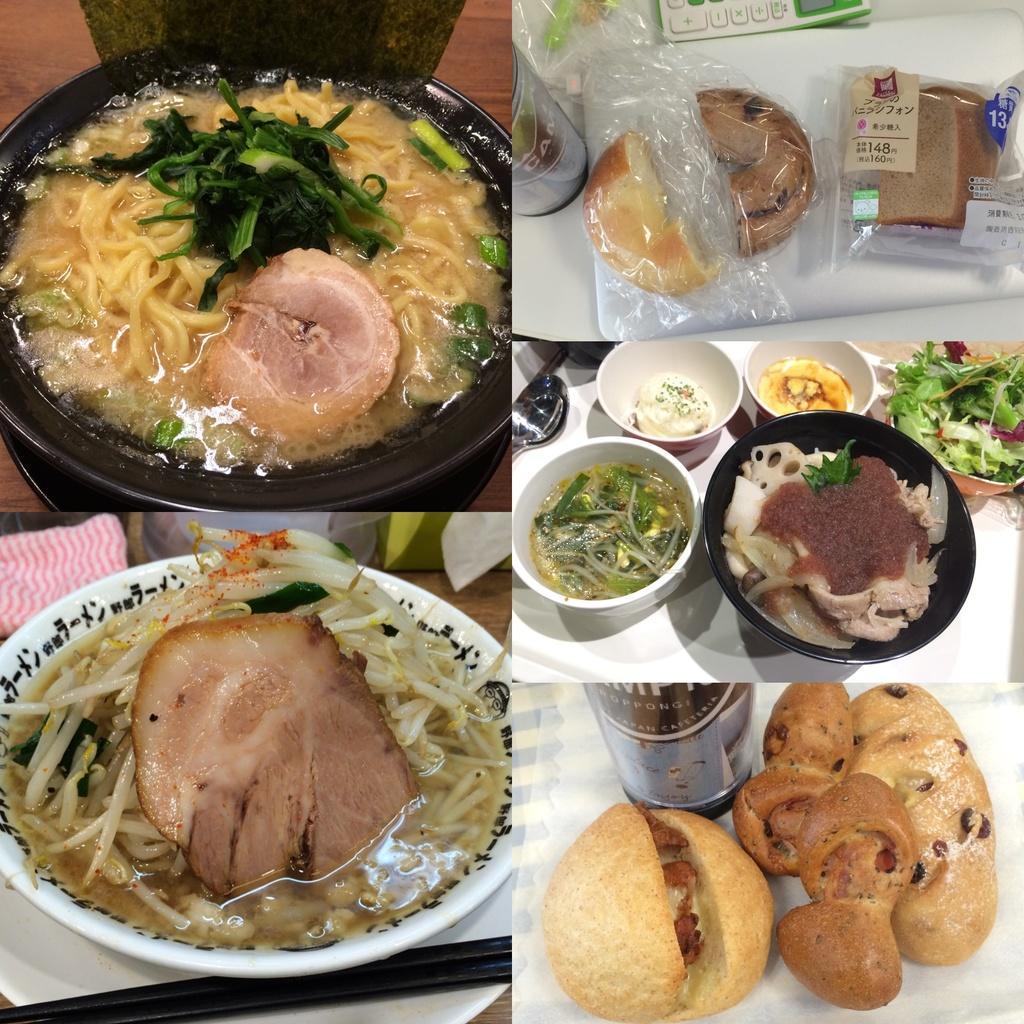Can you describe this image briefly? In the picture I can see so many eatable items are placed in a bowl, which is kept on the table. 